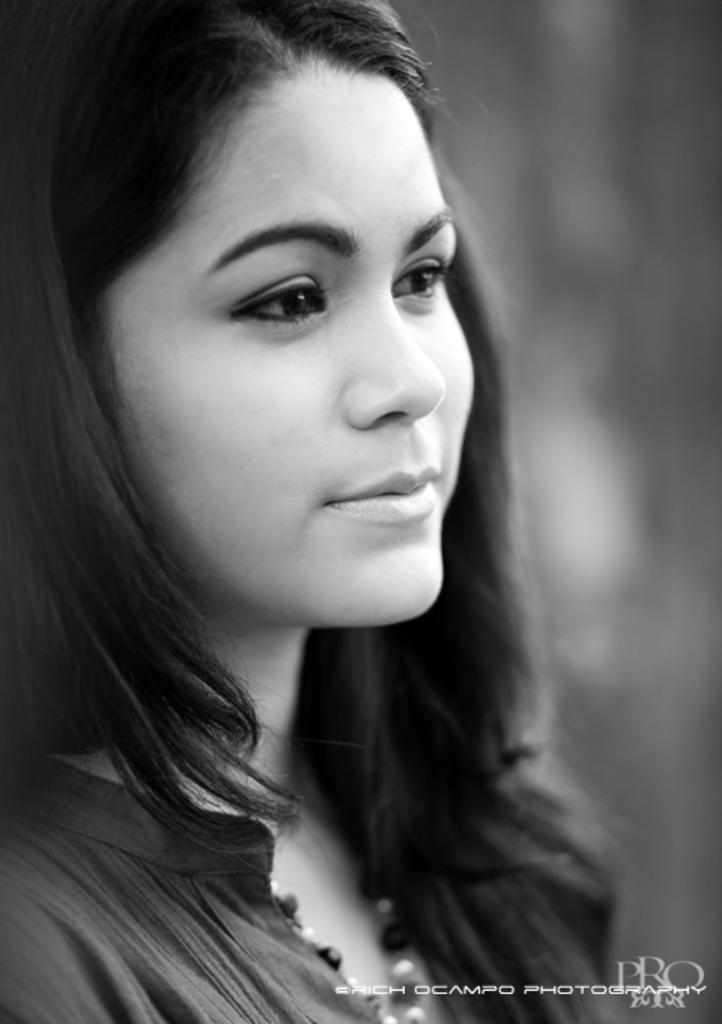What is the main subject of the picture? The main subject of the picture is a woman. Can you describe any other elements in the picture? Yes, there is a poster with a watermark in the picture. How much debt does the worm owe in the image? There is no worm present in the image, so it is not possible to determine any debt owed by a worm. 